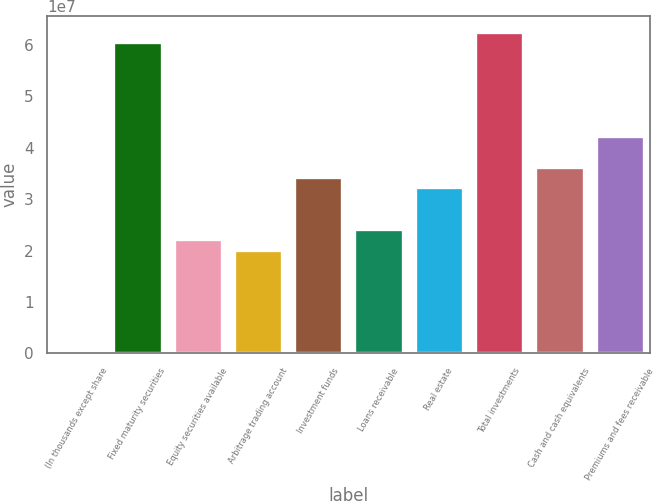Convert chart. <chart><loc_0><loc_0><loc_500><loc_500><bar_chart><fcel>(In thousands except share<fcel>Fixed maturity securities<fcel>Equity securities available<fcel>Arbitrage trading account<fcel>Investment funds<fcel>Loans receivable<fcel>Real estate<fcel>Total investments<fcel>Cash and cash equivalents<fcel>Premiums and fees receivable<nl><fcel>2012<fcel>6.04637e+07<fcel>2.21713e+07<fcel>2.01559e+07<fcel>3.42636e+07<fcel>2.41867e+07<fcel>3.22482e+07<fcel>6.24791e+07<fcel>3.6279e+07<fcel>4.23252e+07<nl></chart> 